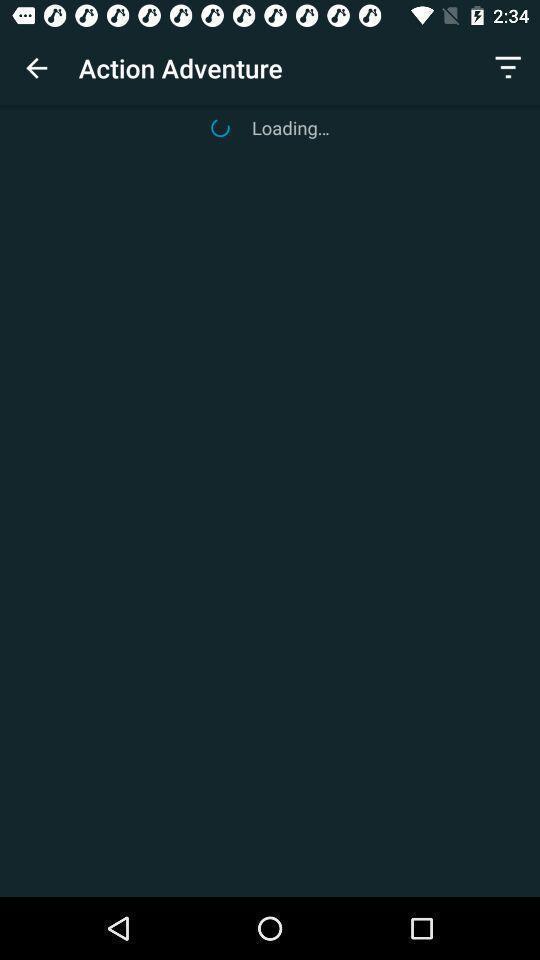Explain what's happening in this screen capture. Search result loading page for entertainment app. 